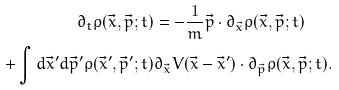Convert formula to latex. <formula><loc_0><loc_0><loc_500><loc_500>\partial _ { t } \rho ( \vec { x } , \vec { p } ; t ) & = - \frac { 1 } { m } \vec { p } \cdot \partial _ { \vec { x } } \rho ( \vec { x } , \vec { p } ; t ) \\ + \int d \vec { x } ^ { \prime } d \vec { p } ^ { \prime } \rho ( \vec { x } ^ { \prime } , \vec { p } ^ { \prime } ; t ) & \partial _ { \vec { x } } V ( \vec { x } - \vec { x } ^ { \prime } ) \cdot \partial _ { \vec { p } } \rho ( \vec { x } , \vec { p } ; t ) .</formula> 